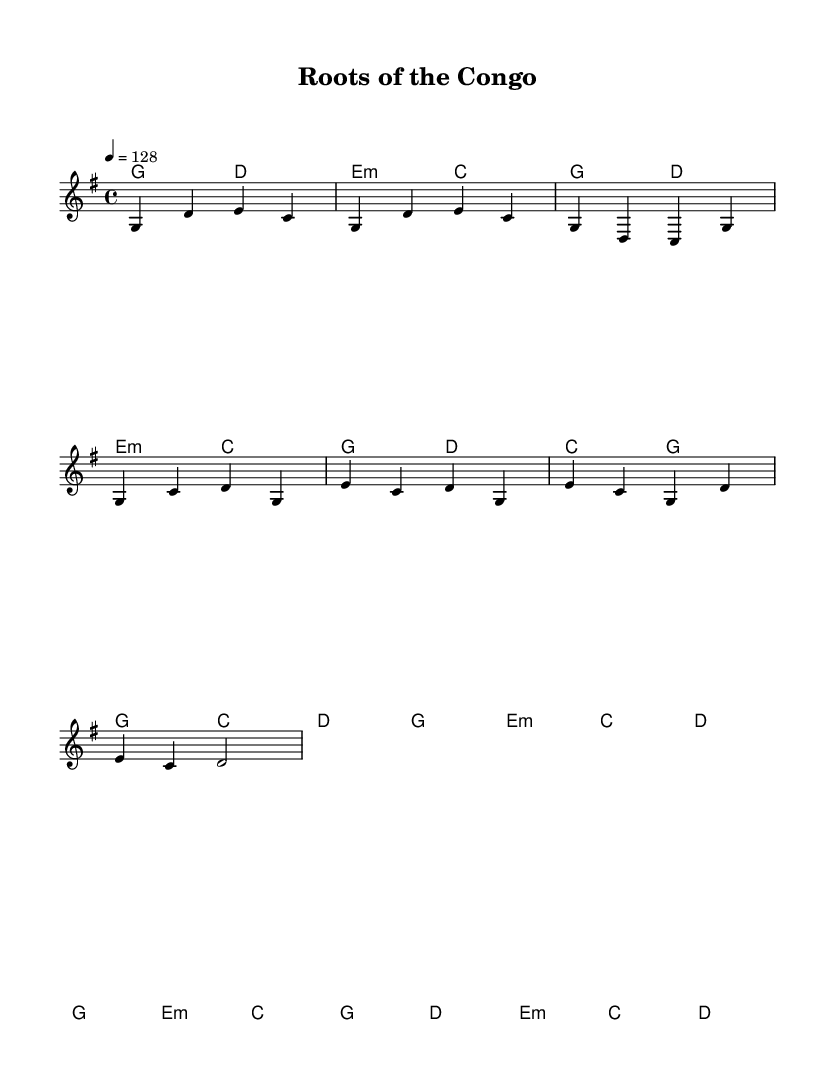What is the key signature of this music? The key signature is G major, which has one sharp (F#). You can determine the key signature by looking at the clef and the accidentals in the piece.
Answer: G major What is the time signature of this piece? The time signature is 4/4, which indicates there are four beats in each measure, and the quarter note gets one beat. This can be identified in the time signature marking displayed at the beginning of the music.
Answer: 4/4 What is the tempo marking for this song? The tempo marking is 128 beats per minute, which indicates the pace at which the piece should be played. This information is located in the tempo instruction at the beginning of the score.
Answer: 128 How many measures are in the chorus section? The chorus section contains 4 measures, which can be counted by analyzing the measures notated in the chorus part of the sheet music. Each grouping of notes separated by vertical lines (bar lines) represents a measure.
Answer: 4 What type of chord is used in the bridge section? The bridge section begins with an E minor chord. This is evident from the chord names indicated above the staff where the specific harmonies are noted for that section.
Answer: E minor How many distinct sections are there in this song? There are four distinct sections in the song: Intro, Verse, Chorus, and Bridge. This can be determined by examining the labels and the organization of the music as it presents different musical ideas.
Answer: 4 What style of music does this piece represent? This piece represents Country Rock, characterized by its upbeat tempo and blend of country music elements with rock influences. The structure and instrumentation hints at this style throughout the song.
Answer: Country Rock 